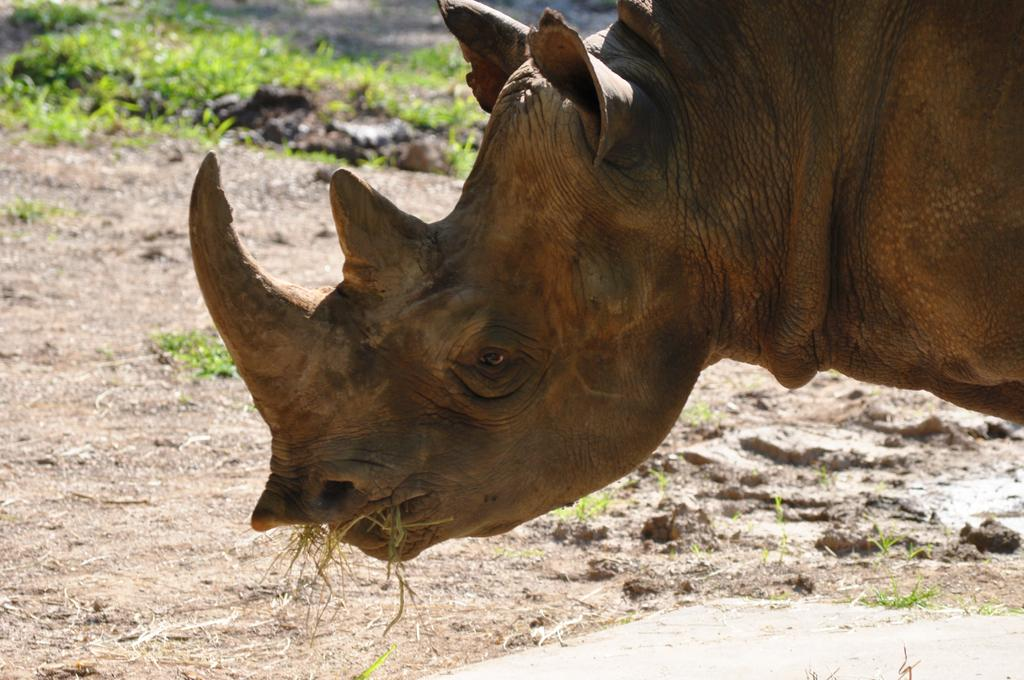What animal is the main subject of the image? There is a rhinoceros in the image. What is the rhinoceros doing in the image? The rhinoceros has grass in its mouth. What can be seen beneath the rhinoceros in the image? The ground is visible in the image. What type of vegetation is present in the background of the image? There is grass in the background of the image. How many girls are playing in the river in the image? There are no girls or rivers present in the image; it features a rhinoceros eating grass. 